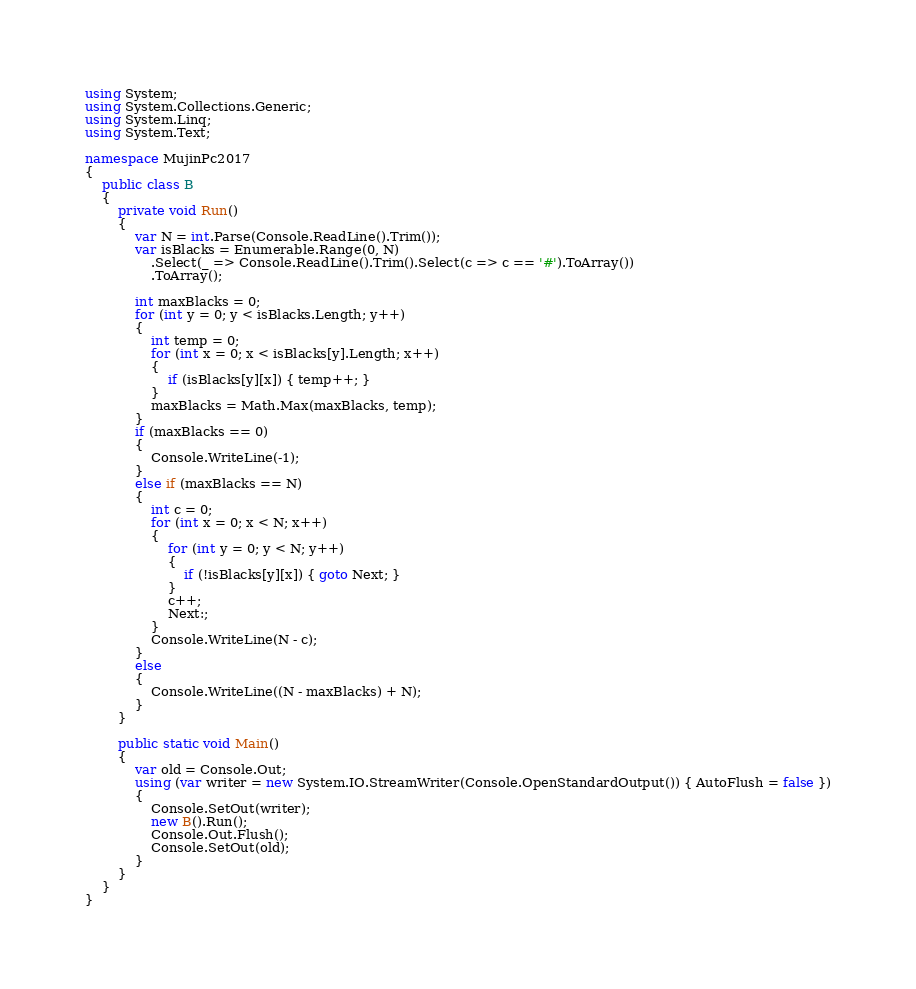Convert code to text. <code><loc_0><loc_0><loc_500><loc_500><_C#_>using System;
using System.Collections.Generic;
using System.Linq;
using System.Text;

namespace MujinPc2017
{
    public class B
    {
        private void Run()
        {
            var N = int.Parse(Console.ReadLine().Trim());
            var isBlacks = Enumerable.Range(0, N)
                .Select(_ => Console.ReadLine().Trim().Select(c => c == '#').ToArray())
                .ToArray();

            int maxBlacks = 0;
            for (int y = 0; y < isBlacks.Length; y++)
            {
                int temp = 0;
                for (int x = 0; x < isBlacks[y].Length; x++)
                {
                    if (isBlacks[y][x]) { temp++; }
                }
                maxBlacks = Math.Max(maxBlacks, temp);
            }
            if (maxBlacks == 0)
            {
                Console.WriteLine(-1);
            }
            else if (maxBlacks == N)
            {
                int c = 0;
                for (int x = 0; x < N; x++)
                {
                    for (int y = 0; y < N; y++)
                    {
                        if (!isBlacks[y][x]) { goto Next; }
                    }
                    c++;
                    Next:;
                }
                Console.WriteLine(N - c);
            }
            else
            {
                Console.WriteLine((N - maxBlacks) + N);
            }
        }

        public static void Main()
        {
            var old = Console.Out;
            using (var writer = new System.IO.StreamWriter(Console.OpenStandardOutput()) { AutoFlush = false })
            {
                Console.SetOut(writer);
                new B().Run();
                Console.Out.Flush();
                Console.SetOut(old);
            }
        }
    }
}
</code> 